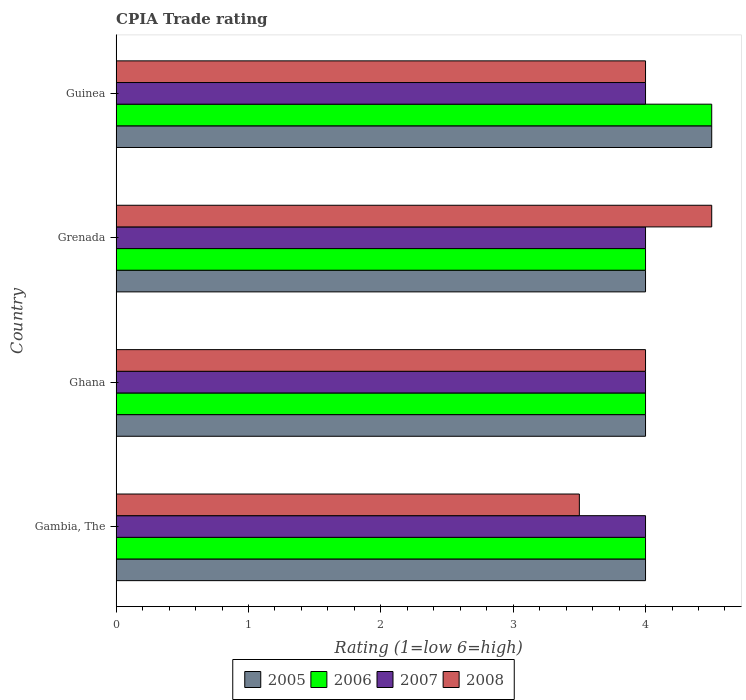How many different coloured bars are there?
Give a very brief answer. 4. How many groups of bars are there?
Provide a succinct answer. 4. Are the number of bars on each tick of the Y-axis equal?
Provide a short and direct response. Yes. How many bars are there on the 1st tick from the top?
Your answer should be compact. 4. What is the label of the 2nd group of bars from the top?
Ensure brevity in your answer.  Grenada. In how many cases, is the number of bars for a given country not equal to the number of legend labels?
Keep it short and to the point. 0. What is the CPIA rating in 2007 in Guinea?
Offer a terse response. 4. Across all countries, what is the maximum CPIA rating in 2008?
Make the answer very short. 4.5. In which country was the CPIA rating in 2007 maximum?
Give a very brief answer. Gambia, The. In which country was the CPIA rating in 2006 minimum?
Provide a short and direct response. Gambia, The. What is the total CPIA rating in 2005 in the graph?
Your answer should be very brief. 16.5. What is the difference between the CPIA rating in 2006 and CPIA rating in 2008 in Ghana?
Your answer should be very brief. 0. In how many countries, is the CPIA rating in 2008 greater than 3 ?
Keep it short and to the point. 4. Is the CPIA rating in 2005 in Gambia, The less than that in Grenada?
Provide a succinct answer. No. What is the difference between the highest and the second highest CPIA rating in 2005?
Your response must be concise. 0.5. In how many countries, is the CPIA rating in 2005 greater than the average CPIA rating in 2005 taken over all countries?
Give a very brief answer. 1. Is the sum of the CPIA rating in 2006 in Ghana and Grenada greater than the maximum CPIA rating in 2005 across all countries?
Provide a succinct answer. Yes. Is it the case that in every country, the sum of the CPIA rating in 2006 and CPIA rating in 2007 is greater than the sum of CPIA rating in 2005 and CPIA rating in 2008?
Your response must be concise. No. What does the 4th bar from the top in Guinea represents?
Your answer should be very brief. 2005. What does the 1st bar from the bottom in Guinea represents?
Provide a short and direct response. 2005. Are all the bars in the graph horizontal?
Keep it short and to the point. Yes. Does the graph contain any zero values?
Your answer should be very brief. No. Does the graph contain grids?
Provide a succinct answer. No. What is the title of the graph?
Offer a terse response. CPIA Trade rating. What is the label or title of the Y-axis?
Your answer should be very brief. Country. What is the Rating (1=low 6=high) of 2006 in Gambia, The?
Keep it short and to the point. 4. What is the Rating (1=low 6=high) of 2008 in Gambia, The?
Give a very brief answer. 3.5. What is the Rating (1=low 6=high) in 2006 in Ghana?
Make the answer very short. 4. What is the Rating (1=low 6=high) of 2008 in Ghana?
Your answer should be very brief. 4. What is the Rating (1=low 6=high) of 2005 in Grenada?
Your response must be concise. 4. What is the Rating (1=low 6=high) in 2006 in Grenada?
Your answer should be very brief. 4. What is the Rating (1=low 6=high) in 2007 in Grenada?
Offer a terse response. 4. What is the Rating (1=low 6=high) of 2008 in Grenada?
Offer a very short reply. 4.5. Across all countries, what is the maximum Rating (1=low 6=high) in 2008?
Make the answer very short. 4.5. Across all countries, what is the minimum Rating (1=low 6=high) of 2007?
Your answer should be compact. 4. Across all countries, what is the minimum Rating (1=low 6=high) in 2008?
Your response must be concise. 3.5. What is the total Rating (1=low 6=high) of 2005 in the graph?
Offer a terse response. 16.5. What is the total Rating (1=low 6=high) in 2006 in the graph?
Offer a very short reply. 16.5. What is the difference between the Rating (1=low 6=high) in 2008 in Gambia, The and that in Ghana?
Offer a very short reply. -0.5. What is the difference between the Rating (1=low 6=high) in 2005 in Gambia, The and that in Grenada?
Offer a very short reply. 0. What is the difference between the Rating (1=low 6=high) of 2006 in Gambia, The and that in Grenada?
Provide a succinct answer. 0. What is the difference between the Rating (1=low 6=high) of 2007 in Gambia, The and that in Guinea?
Your response must be concise. 0. What is the difference between the Rating (1=low 6=high) in 2007 in Ghana and that in Grenada?
Your response must be concise. 0. What is the difference between the Rating (1=low 6=high) of 2008 in Ghana and that in Grenada?
Offer a very short reply. -0.5. What is the difference between the Rating (1=low 6=high) of 2005 in Ghana and that in Guinea?
Make the answer very short. -0.5. What is the difference between the Rating (1=low 6=high) of 2007 in Ghana and that in Guinea?
Offer a terse response. 0. What is the difference between the Rating (1=low 6=high) in 2005 in Grenada and that in Guinea?
Your answer should be very brief. -0.5. What is the difference between the Rating (1=low 6=high) in 2008 in Grenada and that in Guinea?
Your answer should be compact. 0.5. What is the difference between the Rating (1=low 6=high) in 2006 in Gambia, The and the Rating (1=low 6=high) in 2007 in Ghana?
Your answer should be very brief. 0. What is the difference between the Rating (1=low 6=high) of 2007 in Gambia, The and the Rating (1=low 6=high) of 2008 in Ghana?
Make the answer very short. 0. What is the difference between the Rating (1=low 6=high) in 2005 in Gambia, The and the Rating (1=low 6=high) in 2008 in Grenada?
Provide a succinct answer. -0.5. What is the difference between the Rating (1=low 6=high) in 2006 in Gambia, The and the Rating (1=low 6=high) in 2007 in Grenada?
Provide a succinct answer. 0. What is the difference between the Rating (1=low 6=high) of 2006 in Gambia, The and the Rating (1=low 6=high) of 2008 in Grenada?
Your answer should be very brief. -0.5. What is the difference between the Rating (1=low 6=high) of 2007 in Gambia, The and the Rating (1=low 6=high) of 2008 in Grenada?
Give a very brief answer. -0.5. What is the difference between the Rating (1=low 6=high) of 2005 in Gambia, The and the Rating (1=low 6=high) of 2008 in Guinea?
Your response must be concise. 0. What is the difference between the Rating (1=low 6=high) in 2006 in Gambia, The and the Rating (1=low 6=high) in 2007 in Guinea?
Make the answer very short. 0. What is the difference between the Rating (1=low 6=high) in 2005 in Ghana and the Rating (1=low 6=high) in 2006 in Grenada?
Your answer should be very brief. 0. What is the difference between the Rating (1=low 6=high) in 2005 in Ghana and the Rating (1=low 6=high) in 2008 in Grenada?
Offer a very short reply. -0.5. What is the difference between the Rating (1=low 6=high) in 2006 in Ghana and the Rating (1=low 6=high) in 2008 in Grenada?
Provide a short and direct response. -0.5. What is the difference between the Rating (1=low 6=high) of 2005 in Ghana and the Rating (1=low 6=high) of 2007 in Guinea?
Your answer should be compact. 0. What is the difference between the Rating (1=low 6=high) in 2005 in Ghana and the Rating (1=low 6=high) in 2008 in Guinea?
Your answer should be very brief. 0. What is the difference between the Rating (1=low 6=high) of 2006 in Ghana and the Rating (1=low 6=high) of 2008 in Guinea?
Your answer should be compact. 0. What is the difference between the Rating (1=low 6=high) in 2005 in Grenada and the Rating (1=low 6=high) in 2007 in Guinea?
Provide a succinct answer. 0. What is the difference between the Rating (1=low 6=high) of 2005 in Grenada and the Rating (1=low 6=high) of 2008 in Guinea?
Your response must be concise. 0. What is the difference between the Rating (1=low 6=high) of 2007 in Grenada and the Rating (1=low 6=high) of 2008 in Guinea?
Offer a terse response. 0. What is the average Rating (1=low 6=high) of 2005 per country?
Provide a short and direct response. 4.12. What is the average Rating (1=low 6=high) in 2006 per country?
Provide a short and direct response. 4.12. What is the average Rating (1=low 6=high) in 2008 per country?
Make the answer very short. 4. What is the difference between the Rating (1=low 6=high) of 2005 and Rating (1=low 6=high) of 2007 in Gambia, The?
Your response must be concise. 0. What is the difference between the Rating (1=low 6=high) of 2006 and Rating (1=low 6=high) of 2007 in Gambia, The?
Offer a terse response. 0. What is the difference between the Rating (1=low 6=high) of 2006 and Rating (1=low 6=high) of 2008 in Gambia, The?
Offer a terse response. 0.5. What is the difference between the Rating (1=low 6=high) in 2007 and Rating (1=low 6=high) in 2008 in Gambia, The?
Your answer should be compact. 0.5. What is the difference between the Rating (1=low 6=high) of 2005 and Rating (1=low 6=high) of 2006 in Ghana?
Your response must be concise. 0. What is the difference between the Rating (1=low 6=high) of 2005 and Rating (1=low 6=high) of 2007 in Ghana?
Provide a succinct answer. 0. What is the difference between the Rating (1=low 6=high) of 2005 and Rating (1=low 6=high) of 2008 in Ghana?
Offer a terse response. 0. What is the difference between the Rating (1=low 6=high) of 2005 and Rating (1=low 6=high) of 2006 in Grenada?
Provide a short and direct response. 0. What is the difference between the Rating (1=low 6=high) in 2005 and Rating (1=low 6=high) in 2008 in Grenada?
Ensure brevity in your answer.  -0.5. What is the difference between the Rating (1=low 6=high) of 2006 and Rating (1=low 6=high) of 2007 in Grenada?
Ensure brevity in your answer.  0. What is the difference between the Rating (1=low 6=high) of 2007 and Rating (1=low 6=high) of 2008 in Grenada?
Offer a very short reply. -0.5. What is the difference between the Rating (1=low 6=high) of 2005 and Rating (1=low 6=high) of 2007 in Guinea?
Make the answer very short. 0.5. What is the difference between the Rating (1=low 6=high) in 2005 and Rating (1=low 6=high) in 2008 in Guinea?
Your answer should be very brief. 0.5. What is the difference between the Rating (1=low 6=high) of 2006 and Rating (1=low 6=high) of 2007 in Guinea?
Your answer should be very brief. 0.5. What is the difference between the Rating (1=low 6=high) in 2006 and Rating (1=low 6=high) in 2008 in Guinea?
Make the answer very short. 0.5. What is the ratio of the Rating (1=low 6=high) in 2006 in Gambia, The to that in Ghana?
Your answer should be compact. 1. What is the ratio of the Rating (1=low 6=high) in 2005 in Gambia, The to that in Grenada?
Make the answer very short. 1. What is the ratio of the Rating (1=low 6=high) of 2006 in Gambia, The to that in Grenada?
Keep it short and to the point. 1. What is the ratio of the Rating (1=low 6=high) in 2007 in Gambia, The to that in Grenada?
Ensure brevity in your answer.  1. What is the ratio of the Rating (1=low 6=high) of 2008 in Gambia, The to that in Grenada?
Offer a terse response. 0.78. What is the ratio of the Rating (1=low 6=high) of 2005 in Gambia, The to that in Guinea?
Provide a succinct answer. 0.89. What is the ratio of the Rating (1=low 6=high) in 2006 in Gambia, The to that in Guinea?
Ensure brevity in your answer.  0.89. What is the ratio of the Rating (1=low 6=high) in 2007 in Gambia, The to that in Guinea?
Keep it short and to the point. 1. What is the ratio of the Rating (1=low 6=high) in 2008 in Gambia, The to that in Guinea?
Offer a very short reply. 0.88. What is the ratio of the Rating (1=low 6=high) of 2005 in Ghana to that in Grenada?
Your response must be concise. 1. What is the ratio of the Rating (1=low 6=high) of 2007 in Ghana to that in Grenada?
Your answer should be compact. 1. What is the ratio of the Rating (1=low 6=high) in 2006 in Ghana to that in Guinea?
Keep it short and to the point. 0.89. What is the ratio of the Rating (1=low 6=high) in 2007 in Ghana to that in Guinea?
Provide a short and direct response. 1. What is the ratio of the Rating (1=low 6=high) of 2008 in Ghana to that in Guinea?
Your answer should be compact. 1. What is the ratio of the Rating (1=low 6=high) of 2005 in Grenada to that in Guinea?
Your answer should be very brief. 0.89. What is the ratio of the Rating (1=low 6=high) of 2007 in Grenada to that in Guinea?
Keep it short and to the point. 1. What is the ratio of the Rating (1=low 6=high) of 2008 in Grenada to that in Guinea?
Make the answer very short. 1.12. What is the difference between the highest and the second highest Rating (1=low 6=high) of 2007?
Provide a succinct answer. 0. What is the difference between the highest and the second highest Rating (1=low 6=high) in 2008?
Your answer should be compact. 0.5. What is the difference between the highest and the lowest Rating (1=low 6=high) of 2006?
Your response must be concise. 0.5. What is the difference between the highest and the lowest Rating (1=low 6=high) in 2007?
Keep it short and to the point. 0. What is the difference between the highest and the lowest Rating (1=low 6=high) of 2008?
Give a very brief answer. 1. 